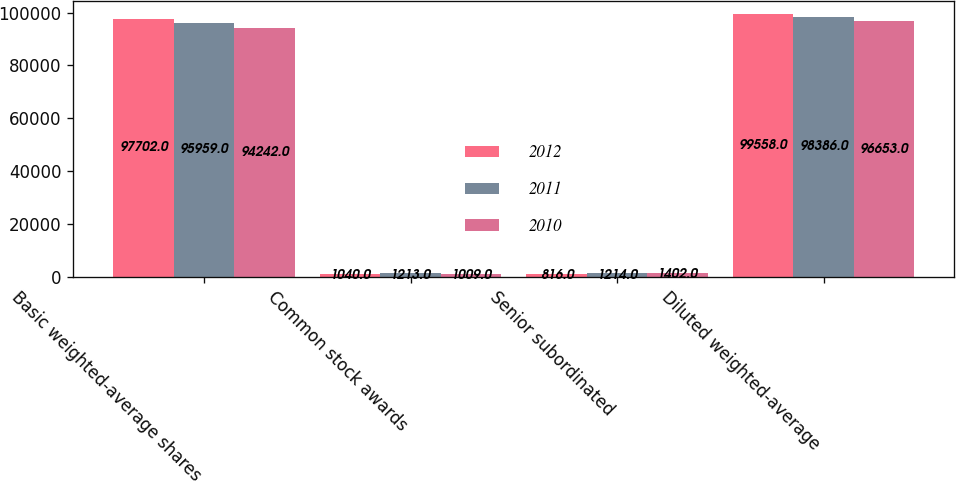Convert chart to OTSL. <chart><loc_0><loc_0><loc_500><loc_500><stacked_bar_chart><ecel><fcel>Basic weighted-average shares<fcel>Common stock awards<fcel>Senior subordinated<fcel>Diluted weighted-average<nl><fcel>2012<fcel>97702<fcel>1040<fcel>816<fcel>99558<nl><fcel>2011<fcel>95959<fcel>1213<fcel>1214<fcel>98386<nl><fcel>2010<fcel>94242<fcel>1009<fcel>1402<fcel>96653<nl></chart> 